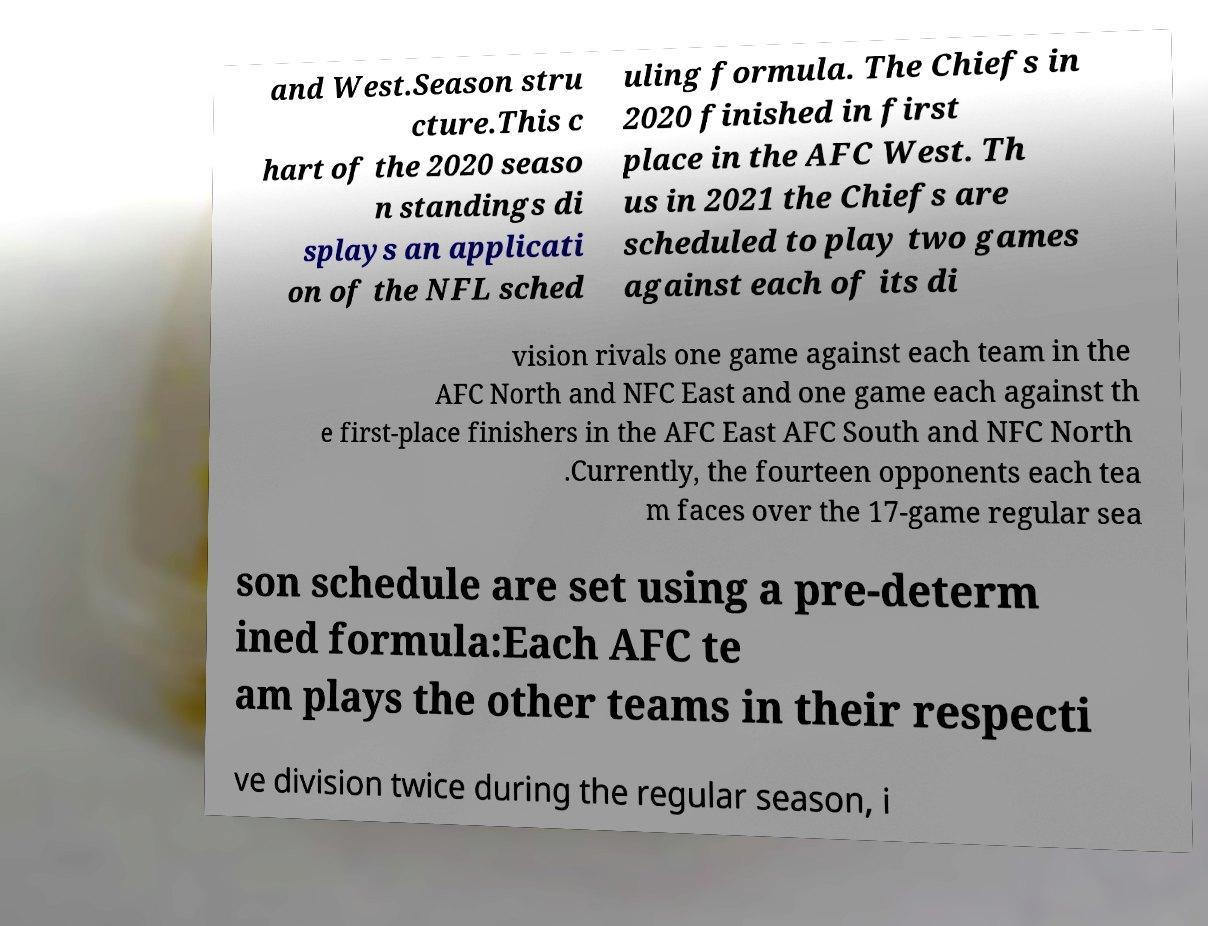Could you assist in decoding the text presented in this image and type it out clearly? and West.Season stru cture.This c hart of the 2020 seaso n standings di splays an applicati on of the NFL sched uling formula. The Chiefs in 2020 finished in first place in the AFC West. Th us in 2021 the Chiefs are scheduled to play two games against each of its di vision rivals one game against each team in the AFC North and NFC East and one game each against th e first-place finishers in the AFC East AFC South and NFC North .Currently, the fourteen opponents each tea m faces over the 17-game regular sea son schedule are set using a pre-determ ined formula:Each AFC te am plays the other teams in their respecti ve division twice during the regular season, i 